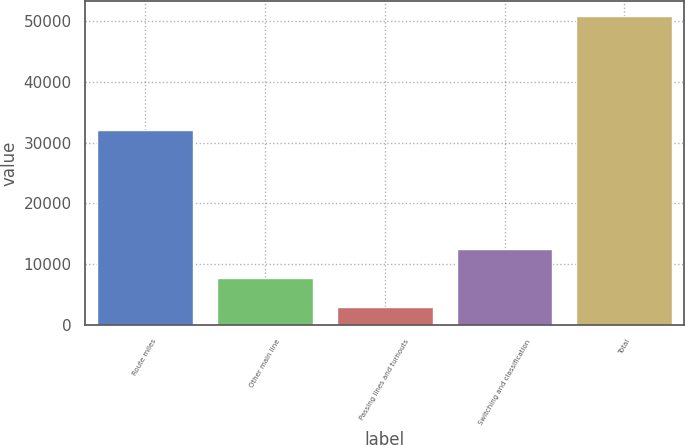Convert chart to OTSL. <chart><loc_0><loc_0><loc_500><loc_500><bar_chart><fcel>Route miles<fcel>Other main line<fcel>Passing lines and turnouts<fcel>Switching and classification<fcel>Total<nl><fcel>32012<fcel>7809.9<fcel>3037<fcel>12582.8<fcel>50766<nl></chart> 